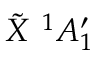<formula> <loc_0><loc_0><loc_500><loc_500>\tilde { X } ^ { 1 } A _ { 1 } ^ { \prime }</formula> 